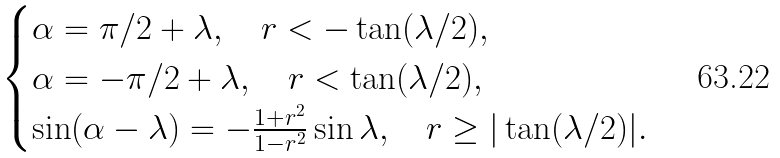<formula> <loc_0><loc_0><loc_500><loc_500>\begin{cases} \alpha = \pi / 2 + \lambda , \quad r < - \tan ( \lambda / 2 ) , \\ \alpha = - \pi / 2 + \lambda , \quad r < \tan ( \lambda / 2 ) , \\ \sin ( \alpha - \lambda ) = - \frac { 1 + r ^ { 2 } } { 1 - r ^ { 2 } } \sin \lambda , \quad r \geq | \tan ( \lambda / 2 ) | . \end{cases}</formula> 